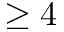Convert formula to latex. <formula><loc_0><loc_0><loc_500><loc_500>\geq 4</formula> 